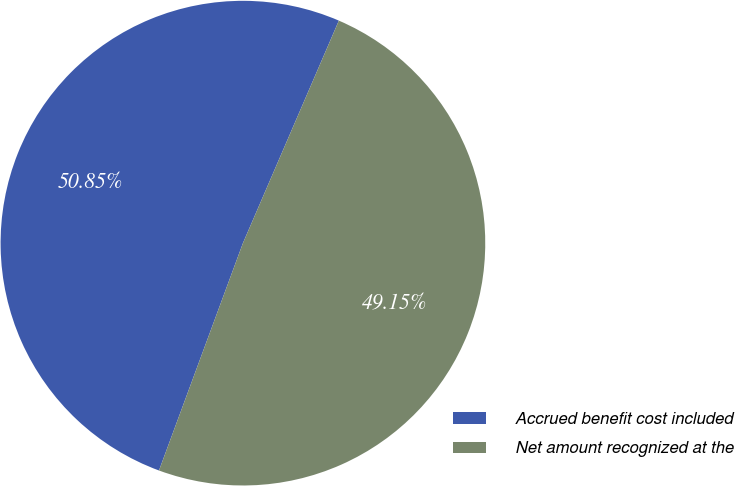Convert chart to OTSL. <chart><loc_0><loc_0><loc_500><loc_500><pie_chart><fcel>Accrued benefit cost included<fcel>Net amount recognized at the<nl><fcel>50.85%<fcel>49.15%<nl></chart> 